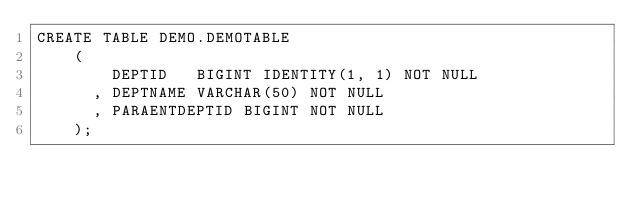<code> <loc_0><loc_0><loc_500><loc_500><_SQL_>CREATE TABLE DEMO.DEMOTABLE
    (
        DEPTID   BIGINT IDENTITY(1, 1) NOT NULL
      , DEPTNAME VARCHAR(50) NOT NULL
      , PARAENTDEPTID BIGINT NOT NULL
    );</code> 